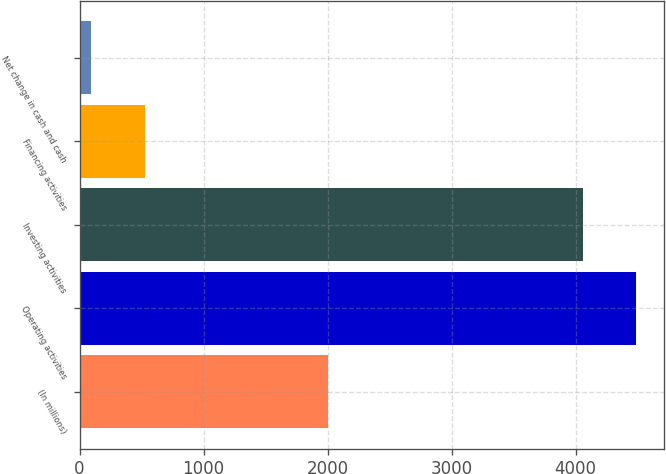Convert chart. <chart><loc_0><loc_0><loc_500><loc_500><bar_chart><fcel>(In millions)<fcel>Operating activities<fcel>Investing activities<fcel>Financing activities<fcel>Net change in cash and cash<nl><fcel>2006<fcel>4487.3<fcel>4057<fcel>524.3<fcel>94<nl></chart> 